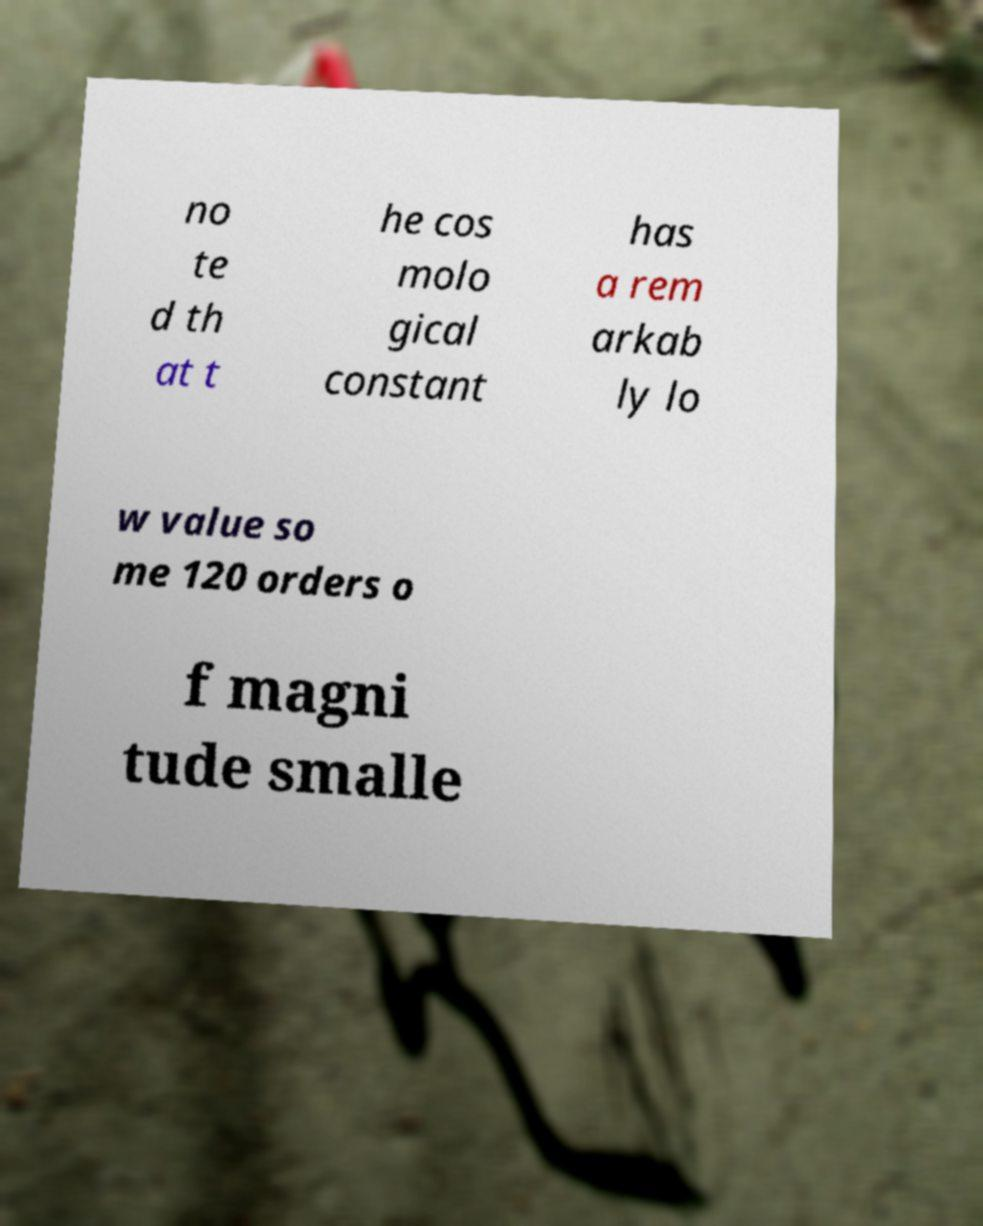Please identify and transcribe the text found in this image. no te d th at t he cos molo gical constant has a rem arkab ly lo w value so me 120 orders o f magni tude smalle 